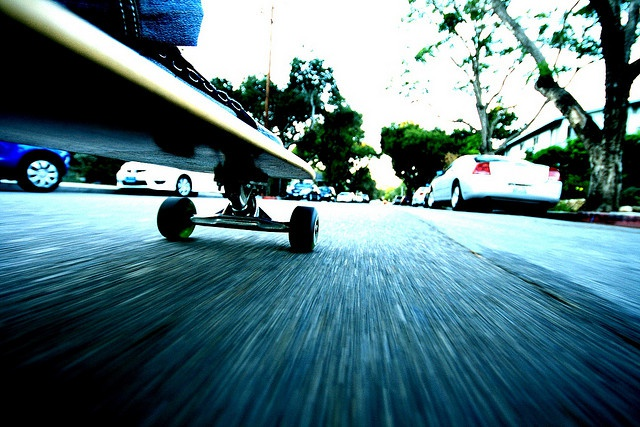Describe the objects in this image and their specific colors. I can see skateboard in green, black, ivory, teal, and darkblue tones, car in green, white, black, and lightblue tones, people in green, black, navy, blue, and lightblue tones, car in green, black, blue, cyan, and darkblue tones, and car in green, white, black, and lightblue tones in this image. 